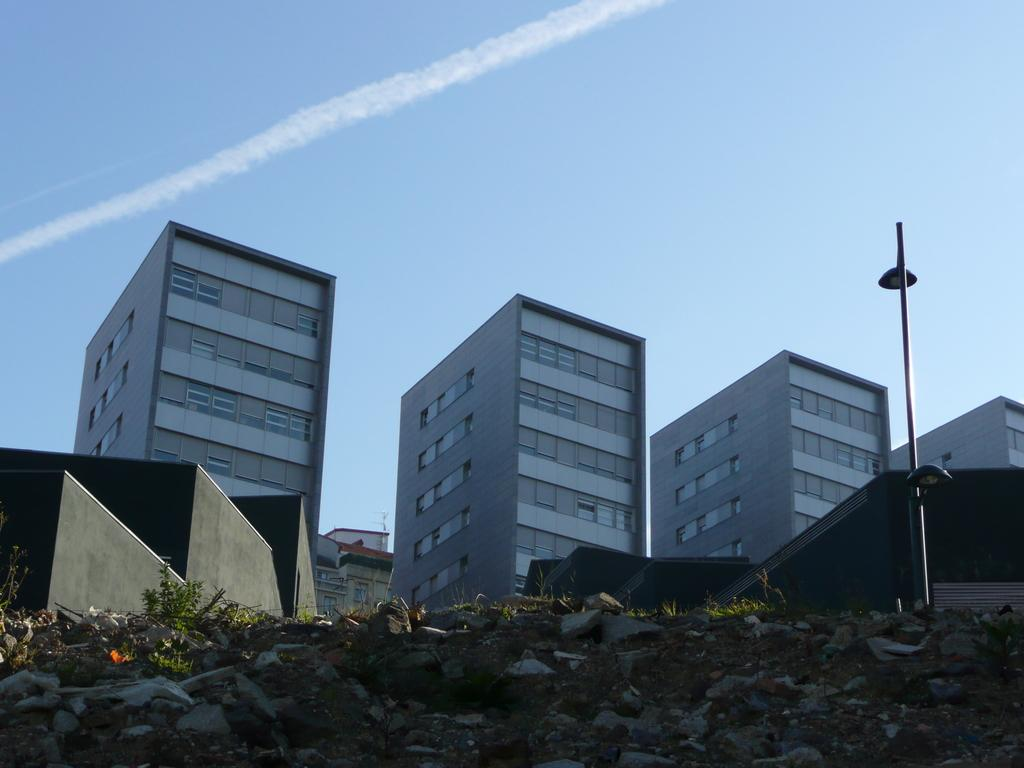What type of surface can be seen in the image? There is ground visible in the image. the image. What natural elements are present in the image? There are plants and rocks in the image. What man-made object can be seen in the image? There is a pole in the image. What can be seen in the background of the image? There are buildings and the sky visible in the background of the image. Can you see any frogs drinking eggnog in the image? There are no frogs or eggnog present in the image. What type of writing can be seen on the pole in the image? There is no writing visible on the pole in the image. 